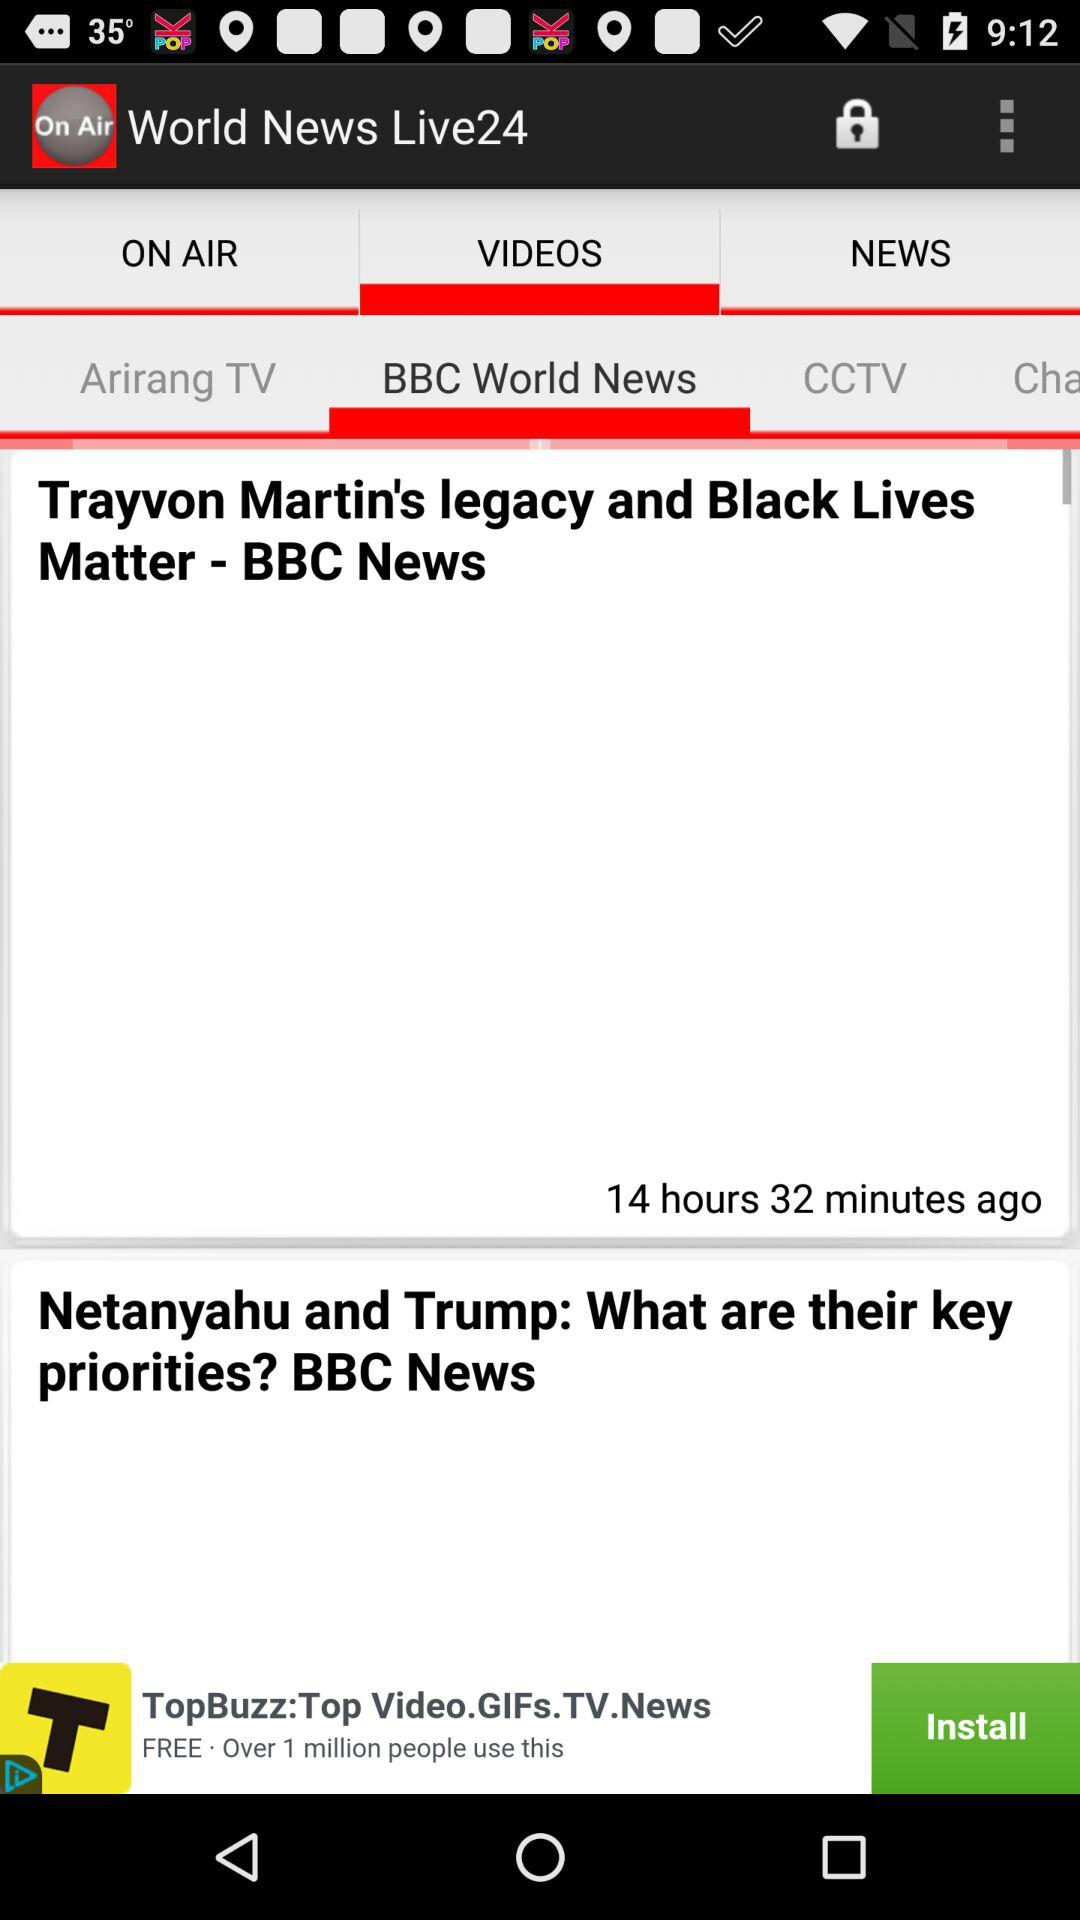Which television channel is selected? The selected television channel is "BBC World News". 